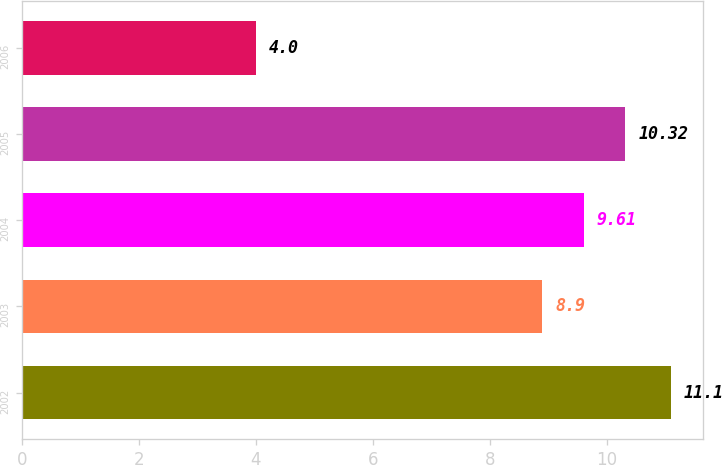Convert chart to OTSL. <chart><loc_0><loc_0><loc_500><loc_500><bar_chart><fcel>2002<fcel>2003<fcel>2004<fcel>2005<fcel>2006<nl><fcel>11.1<fcel>8.9<fcel>9.61<fcel>10.32<fcel>4<nl></chart> 